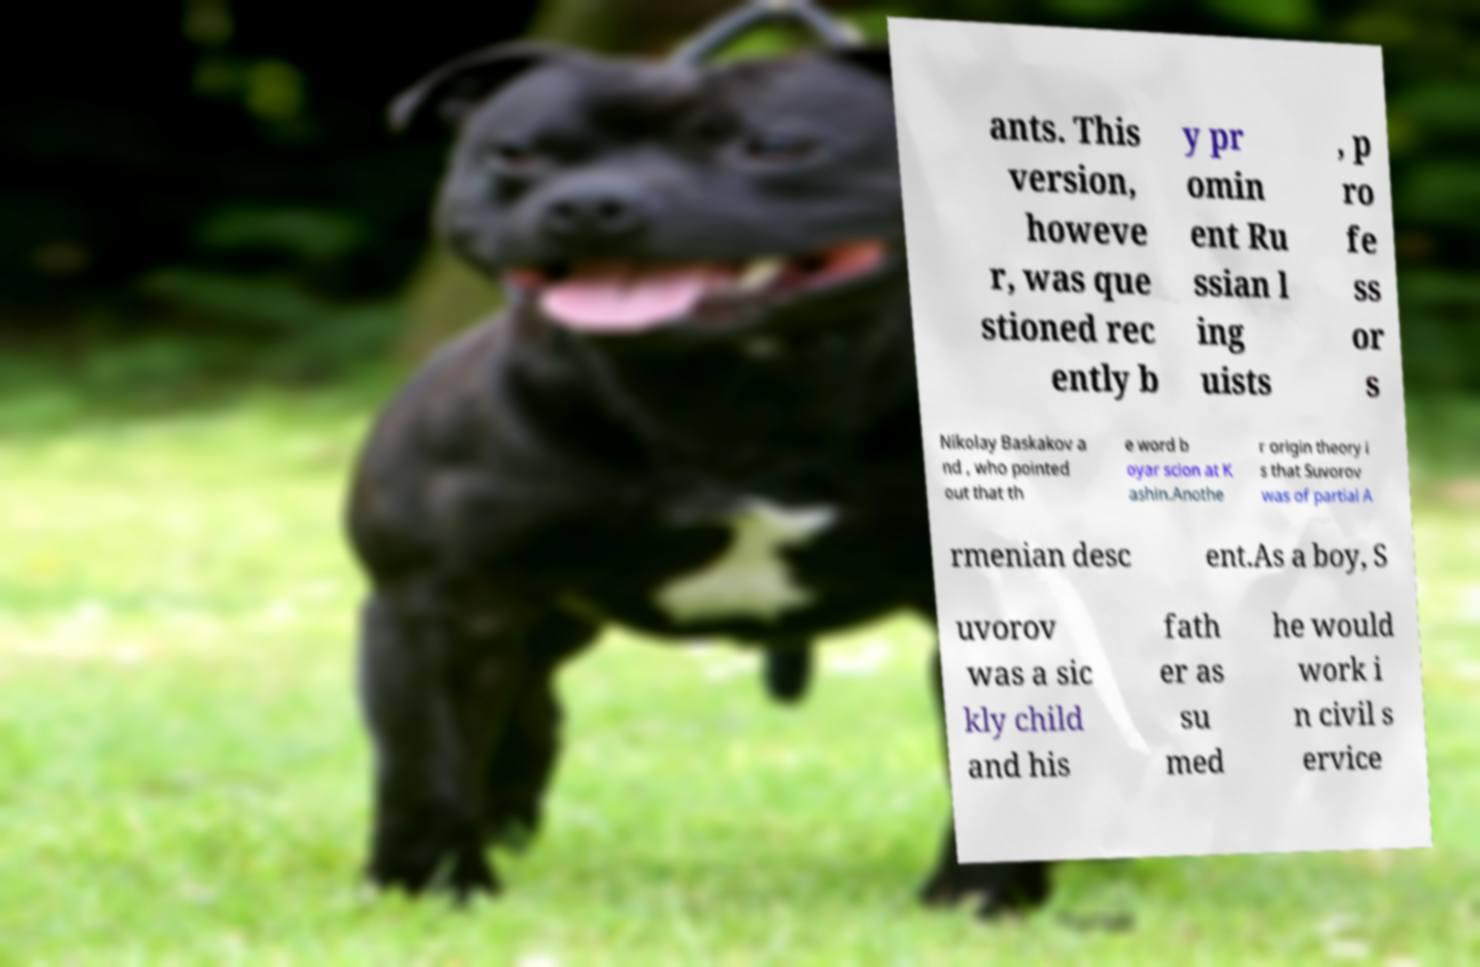Could you extract and type out the text from this image? ants. This version, howeve r, was que stioned rec ently b y pr omin ent Ru ssian l ing uists , p ro fe ss or s Nikolay Baskakov a nd , who pointed out that th e word b oyar scion at K ashin.Anothe r origin theory i s that Suvorov was of partial A rmenian desc ent.As a boy, S uvorov was a sic kly child and his fath er as su med he would work i n civil s ervice 